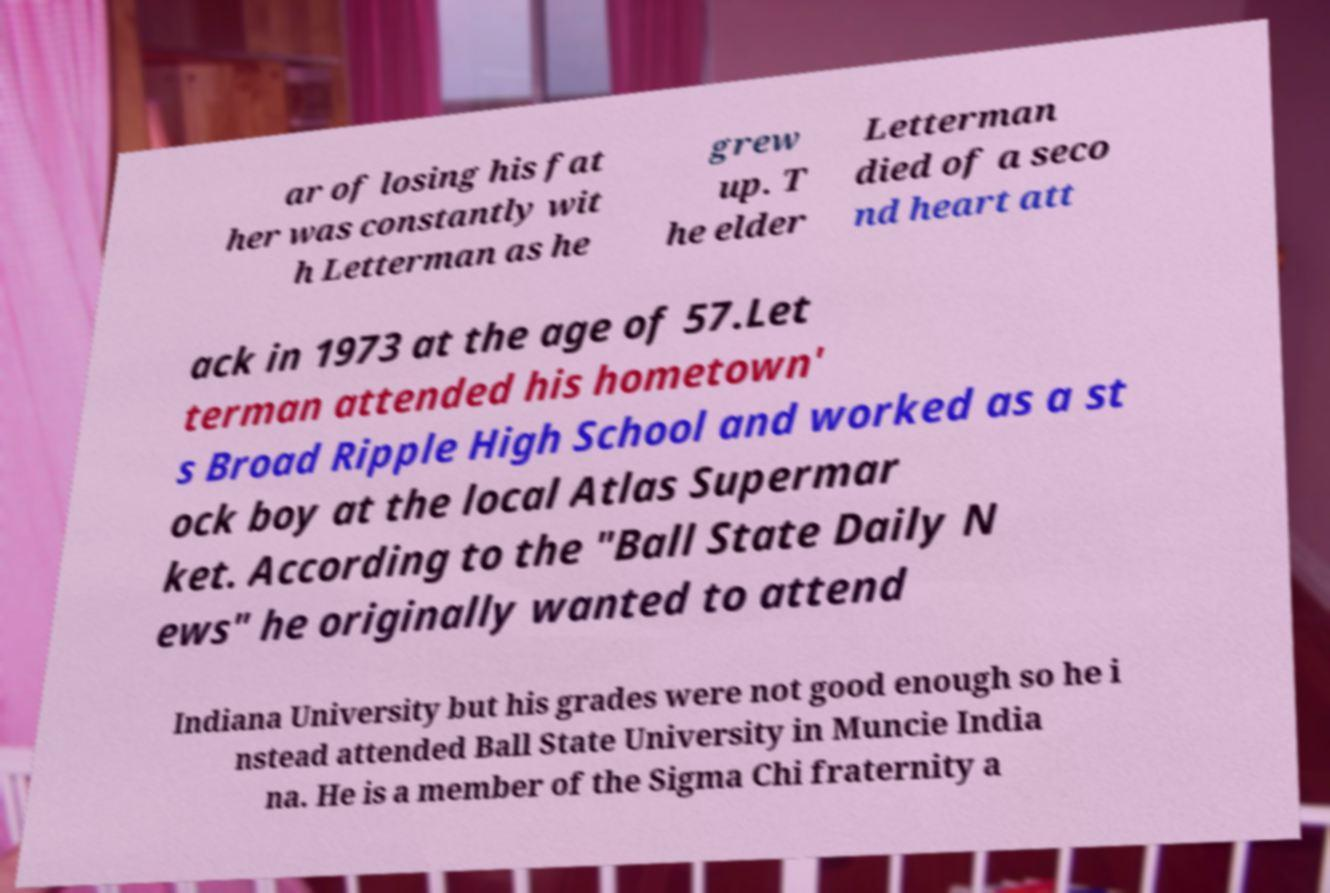I need the written content from this picture converted into text. Can you do that? ar of losing his fat her was constantly wit h Letterman as he grew up. T he elder Letterman died of a seco nd heart att ack in 1973 at the age of 57.Let terman attended his hometown' s Broad Ripple High School and worked as a st ock boy at the local Atlas Supermar ket. According to the "Ball State Daily N ews" he originally wanted to attend Indiana University but his grades were not good enough so he i nstead attended Ball State University in Muncie India na. He is a member of the Sigma Chi fraternity a 